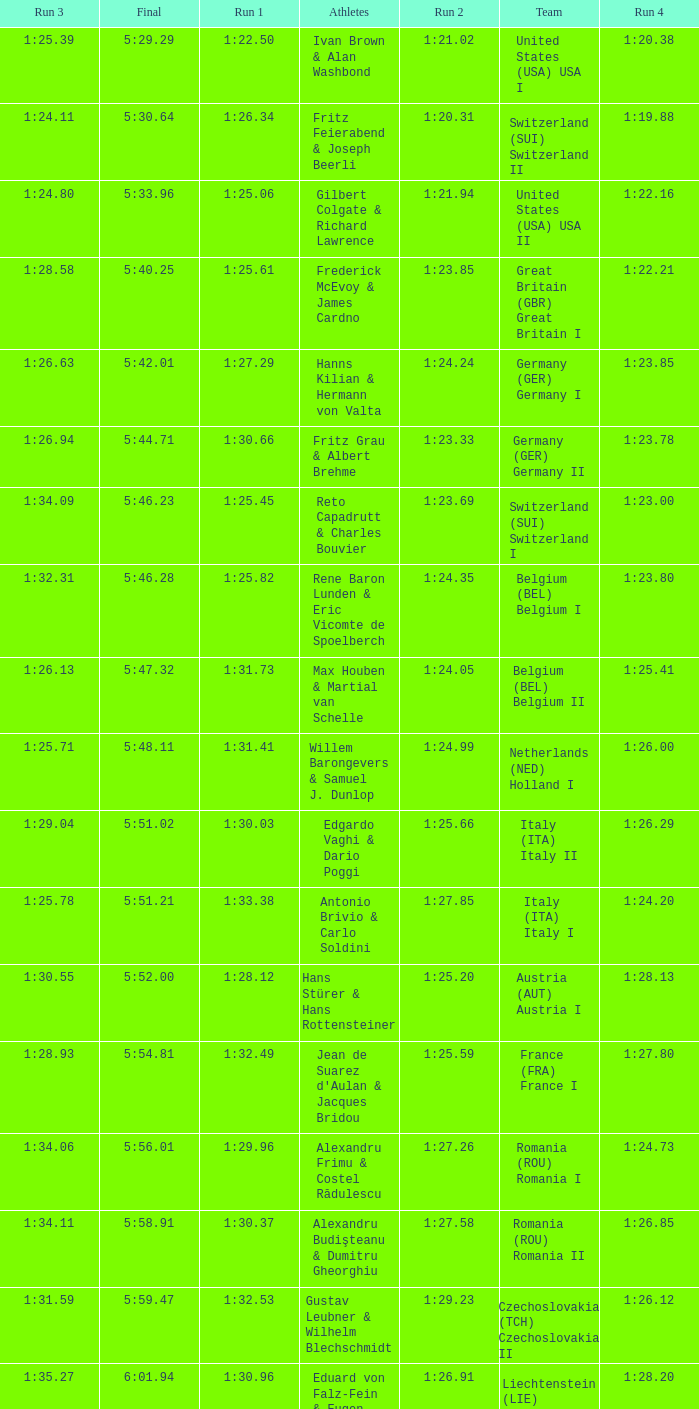Which Run 4 has a Run 1 of 1:25.82? 1:23.80. 